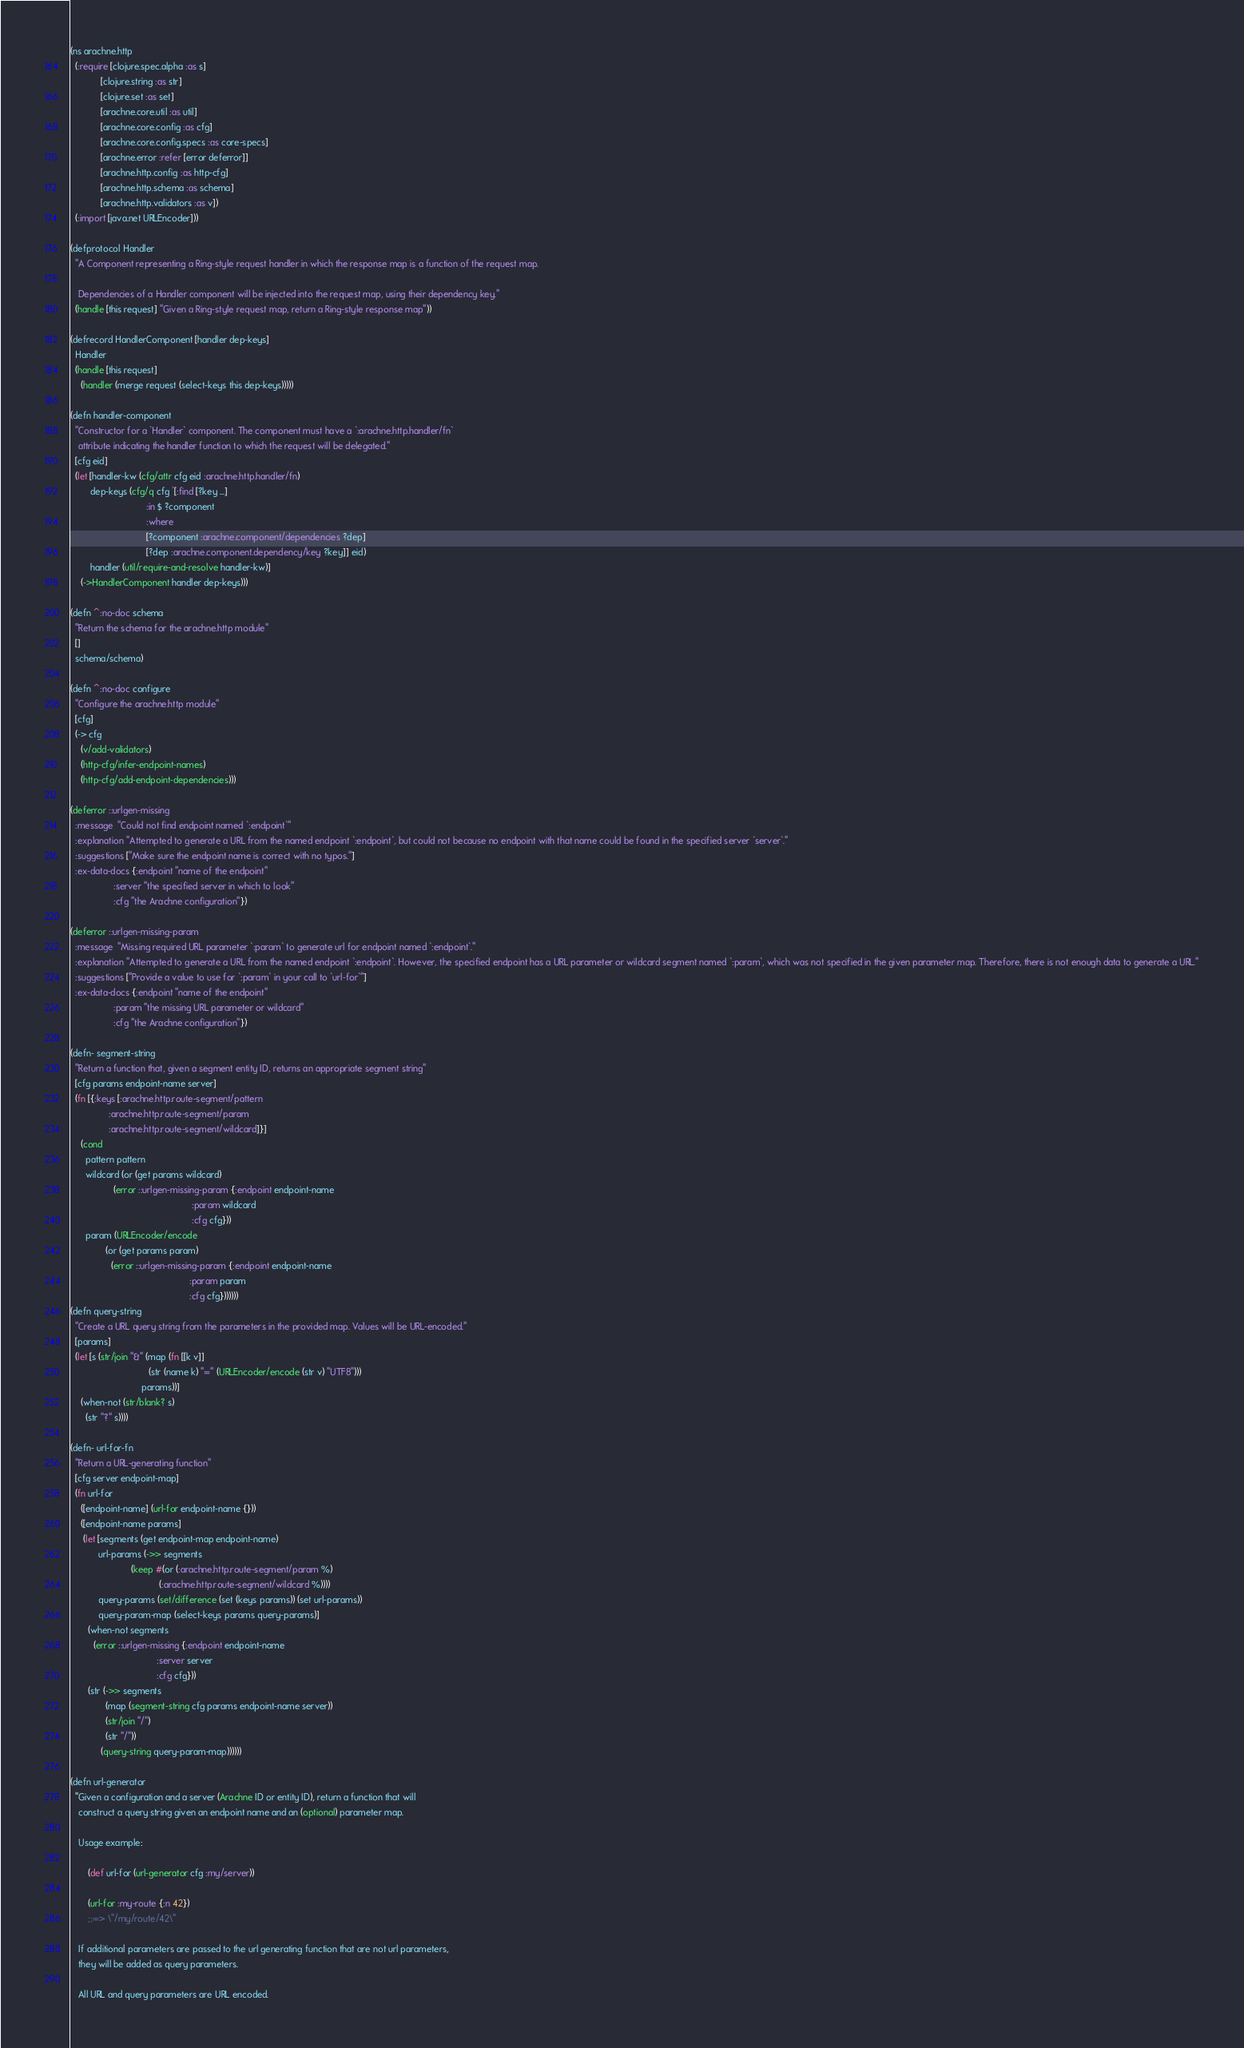<code> <loc_0><loc_0><loc_500><loc_500><_Clojure_>(ns arachne.http
  (:require [clojure.spec.alpha :as s]
            [clojure.string :as str]
            [clojure.set :as set]
            [arachne.core.util :as util]
            [arachne.core.config :as cfg]
            [arachne.core.config.specs :as core-specs]
            [arachne.error :refer [error deferror]]
            [arachne.http.config :as http-cfg]
            [arachne.http.schema :as schema]
            [arachne.http.validators :as v])
  (:import [java.net URLEncoder]))

(defprotocol Handler
  "A Component representing a Ring-style request handler in which the response map is a function of the request map.

   Dependencies of a Handler component will be injected into the request map, using their dependency key."
  (handle [this request] "Given a Ring-style request map, return a Ring-style response map"))

(defrecord HandlerComponent [handler dep-keys]
  Handler
  (handle [this request]
    (handler (merge request (select-keys this dep-keys)))))

(defn handler-component
  "Constructor for a `Handler` component. The component must have a `:arachne.http.handler/fn`
   attribute indicating the handler function to which the request will be delegated."
  [cfg eid]
  (let [handler-kw (cfg/attr cfg eid :arachne.http.handler/fn)
        dep-keys (cfg/q cfg '[:find [?key ...]
                              :in $ ?component
                              :where
                              [?component :arachne.component/dependencies ?dep]
                              [?dep :arachne.component.dependency/key ?key]] eid)
        handler (util/require-and-resolve handler-kw)]
    (->HandlerComponent handler dep-keys)))

(defn ^:no-doc schema
  "Return the schema for the arachne.http module"
  []
  schema/schema)

(defn ^:no-doc configure
  "Configure the arachne.http module"
  [cfg]
  (-> cfg
    (v/add-validators)
    (http-cfg/infer-endpoint-names)
    (http-cfg/add-endpoint-dependencies)))

(deferror ::urlgen-missing
  :message  "Could not find endpoint named `:endpoint`"
  :explanation "Attempted to generate a URL from the named endpoint `:endpoint`, but could not because no endpoint with that name could be found in the specified server `server`."
  :suggestions ["Make sure the endpoint name is correct with no typos."]
  :ex-data-docs {:endpoint "name of the endpoint"
                 :server "the specified server in which to look"
                 :cfg "the Arachne configuration"})

(deferror ::urlgen-missing-param
  :message  "Missing required URL parameter `:param` to generate url for endpoint named `:endpoint`."
  :explanation "Attempted to generate a URL from the named endpoint `:endpoint`. However, the specified endpoint has a URL parameter or wildcard segment named `:param`, which was not specified in the given parameter map. Therefore, there is not enough data to generate a URL."
  :suggestions ["Provide a value to use for `:param` in your call to `url-for`"]
  :ex-data-docs {:endpoint "name of the endpoint"
                 :param "the missing URL parameter or wildcard"
                 :cfg "the Arachne configuration"})

(defn- segment-string
  "Return a function that, given a segment entity ID, returns an appropriate segment string"
  [cfg params endpoint-name server]
  (fn [{:keys [:arachne.http.route-segment/pattern
               :arachne.http.route-segment/param
               :arachne.http.route-segment/wildcard]}]
    (cond
      pattern pattern
      wildcard (or (get params wildcard)
                 (error ::urlgen-missing-param {:endpoint endpoint-name
                                                :param wildcard
                                                :cfg cfg}))
      param (URLEncoder/encode
              (or (get params param)
                (error ::urlgen-missing-param {:endpoint endpoint-name
                                               :param param
                                               :cfg cfg}))))))
(defn query-string
  "Create a URL query string from the parameters in the provided map. Values will be URL-encoded."
  [params]
  (let [s (str/join "&" (map (fn [[k v]]
                               (str (name k) "=" (URLEncoder/encode (str v) "UTF8")))
                            params))]
    (when-not (str/blank? s)
      (str "?" s))))

(defn- url-for-fn
  "Return a URL-generating function"
  [cfg server endpoint-map]
  (fn url-for
    ([endpoint-name] (url-for endpoint-name {}))
    ([endpoint-name params]
     (let [segments (get endpoint-map endpoint-name)
           url-params (->> segments
                        (keep #(or (:arachne.http.route-segment/param %)
                                   (:arachne.http.route-segment/wildcard %))))
           query-params (set/difference (set (keys params)) (set url-params))
           query-param-map (select-keys params query-params)]
       (when-not segments
         (error ::urlgen-missing {:endpoint endpoint-name
                                  :server server
                                  :cfg cfg}))
       (str (->> segments
              (map (segment-string cfg params endpoint-name server))
              (str/join "/")
              (str "/"))
            (query-string query-param-map))))))

(defn url-generator
  "Given a configuration and a server (Arachne ID or entity ID), return a function that will
   construct a query string given an endpoint name and an (optional) parameter map.

   Usage example:

       (def url-for (url-generator cfg :my/server))

       (url-for :my-route {:n 42})
       ;;=> \"/my/route/42\"

   If additional parameters are passed to the url generating function that are not url parameters,
   they will be added as query parameters.

   All URL and query parameters are URL encoded.
</code> 